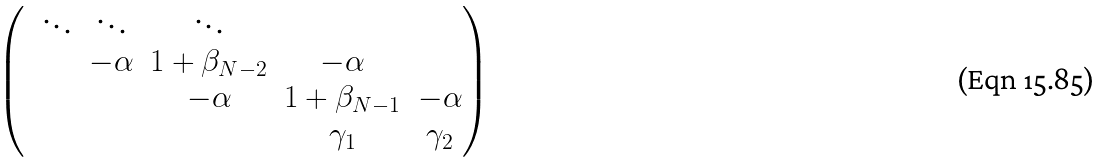<formula> <loc_0><loc_0><loc_500><loc_500>\begin{pmatrix} & \ddots & \ddots & \ddots & & \\ & & - \alpha & 1 + \beta _ { N - 2 } & - \alpha & \\ & & & - \alpha & 1 + \beta _ { N - 1 } & - \alpha \\ & & & & \gamma _ { 1 } & \gamma _ { 2 } \end{pmatrix}</formula> 